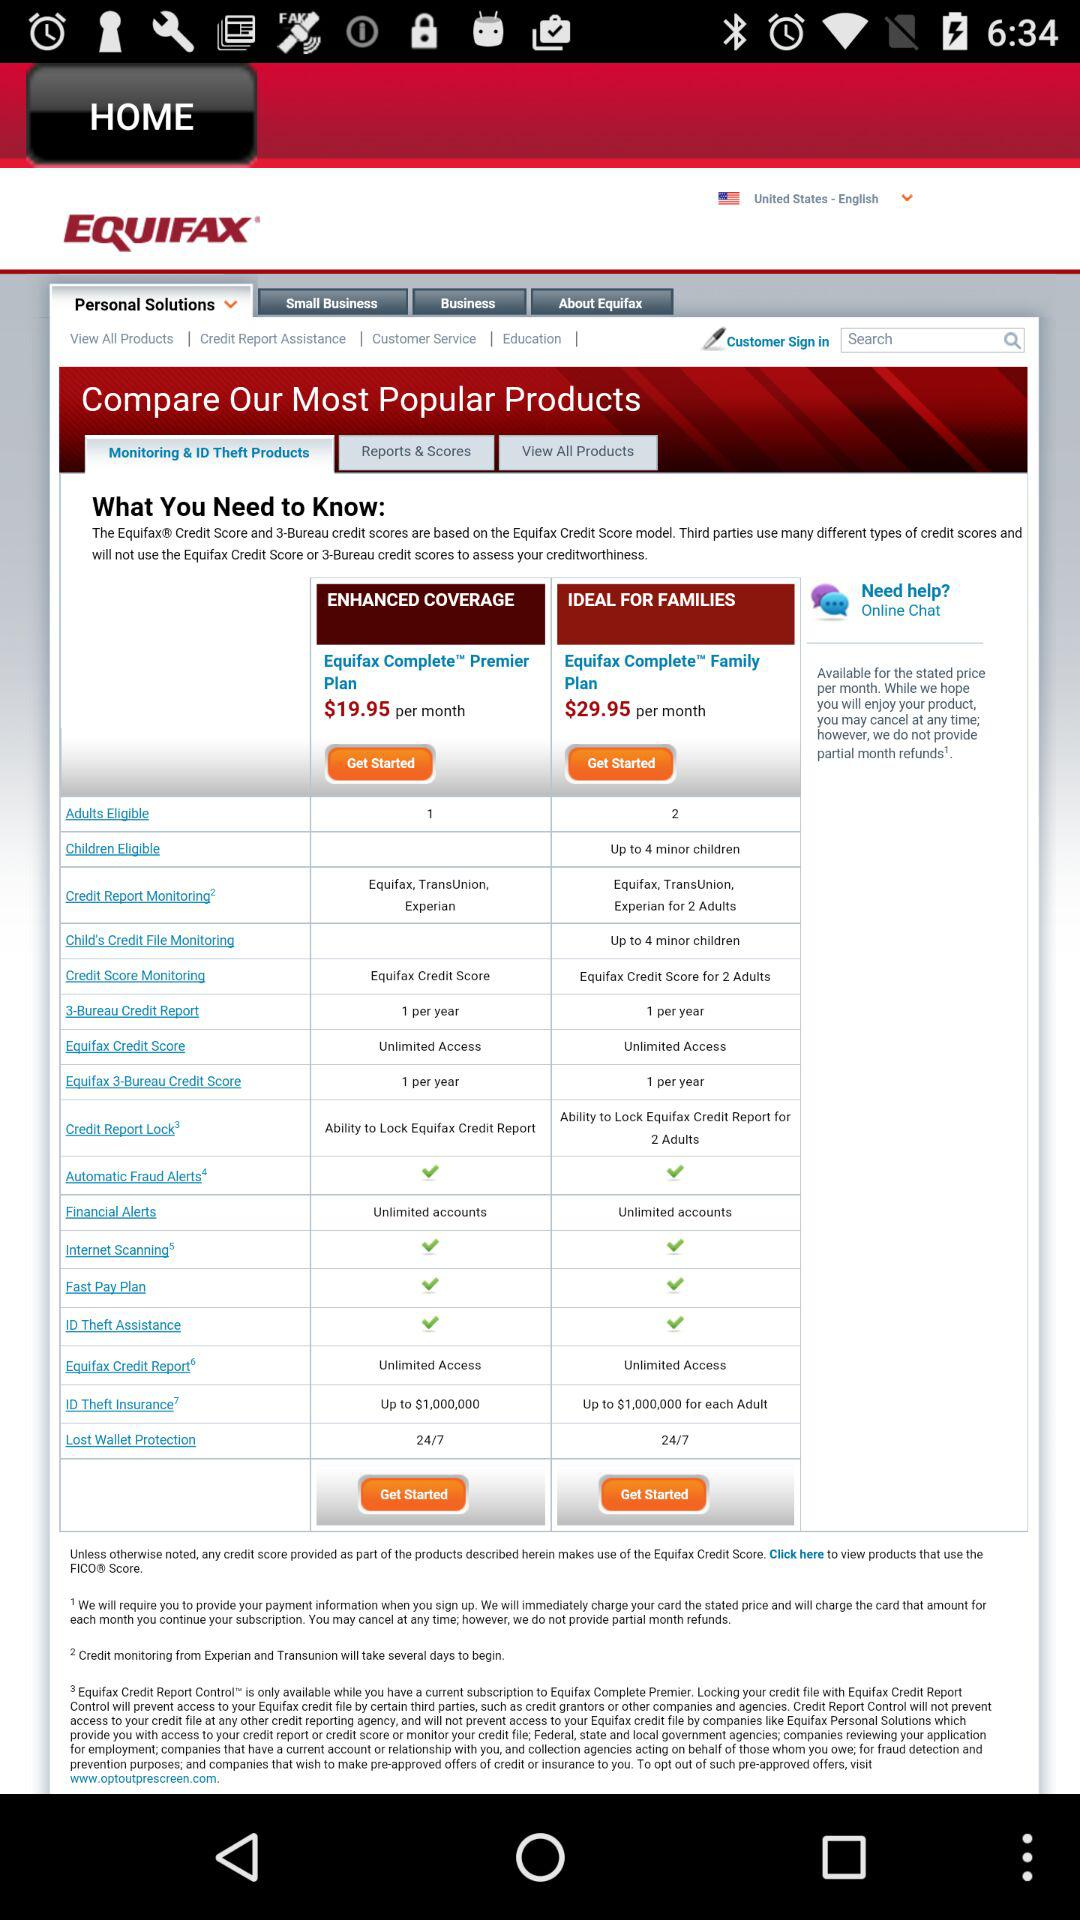Which country and language are selected? The selected country is the United States, and the language is English. 